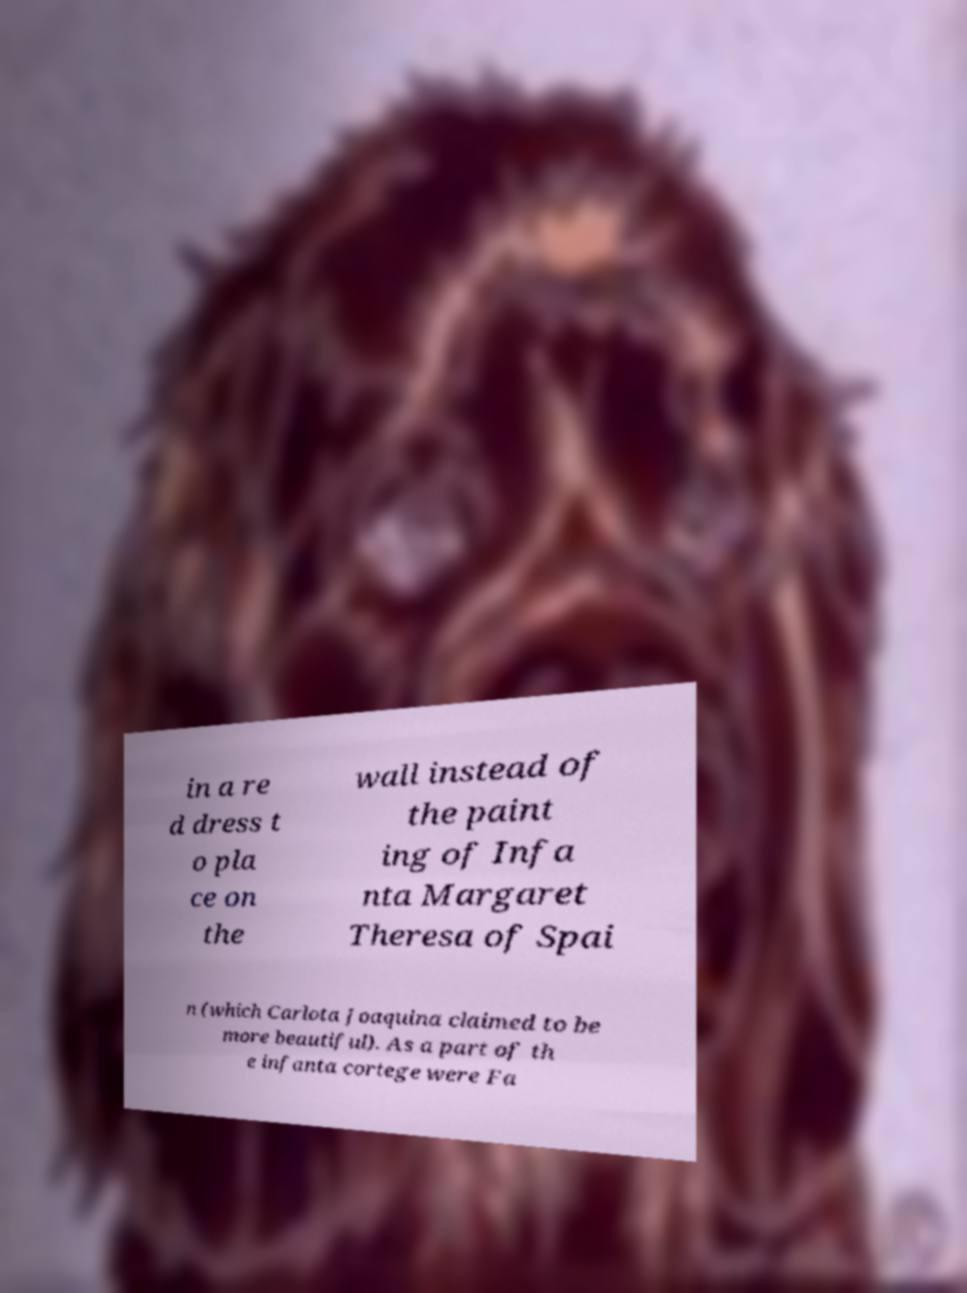Please identify and transcribe the text found in this image. in a re d dress t o pla ce on the wall instead of the paint ing of Infa nta Margaret Theresa of Spai n (which Carlota Joaquina claimed to be more beautiful). As a part of th e infanta cortege were Fa 